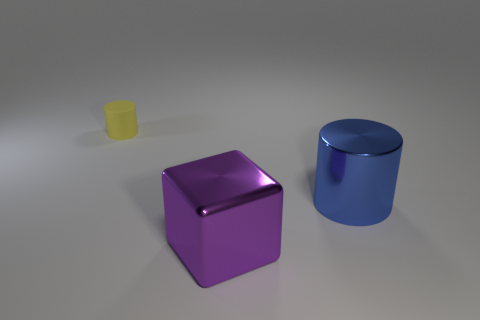Do the cylinder right of the yellow rubber object and the big block have the same color?
Your response must be concise. No. There is a cylinder that is on the left side of the large shiny thing that is behind the big purple cube; are there any tiny yellow cylinders that are behind it?
Provide a succinct answer. No. There is a object that is both to the left of the big blue metal object and to the right of the yellow matte object; what shape is it?
Your answer should be compact. Cube. Are there any other shiny cylinders of the same color as the large cylinder?
Your response must be concise. No. What is the color of the big metal object that is right of the big thing that is on the left side of the big blue shiny cylinder?
Offer a very short reply. Blue. What is the size of the object on the left side of the thing that is in front of the object to the right of the cube?
Your response must be concise. Small. Do the purple cube and the object to the right of the large purple metal thing have the same material?
Offer a terse response. Yes. What is the size of the blue thing that is the same material as the block?
Provide a succinct answer. Large. Is there a brown shiny object that has the same shape as the purple thing?
Offer a terse response. No. What number of objects are cylinders that are on the right side of the tiny yellow matte cylinder or gray shiny cylinders?
Ensure brevity in your answer.  1. 